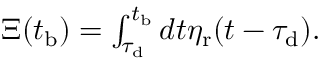<formula> <loc_0><loc_0><loc_500><loc_500>\begin{array} { r } { \Xi ( t _ { b } ) = \int _ { \tau _ { d } } ^ { t _ { b } } d t \eta _ { r } ( t - \tau _ { d } ) . } \end{array}</formula> 